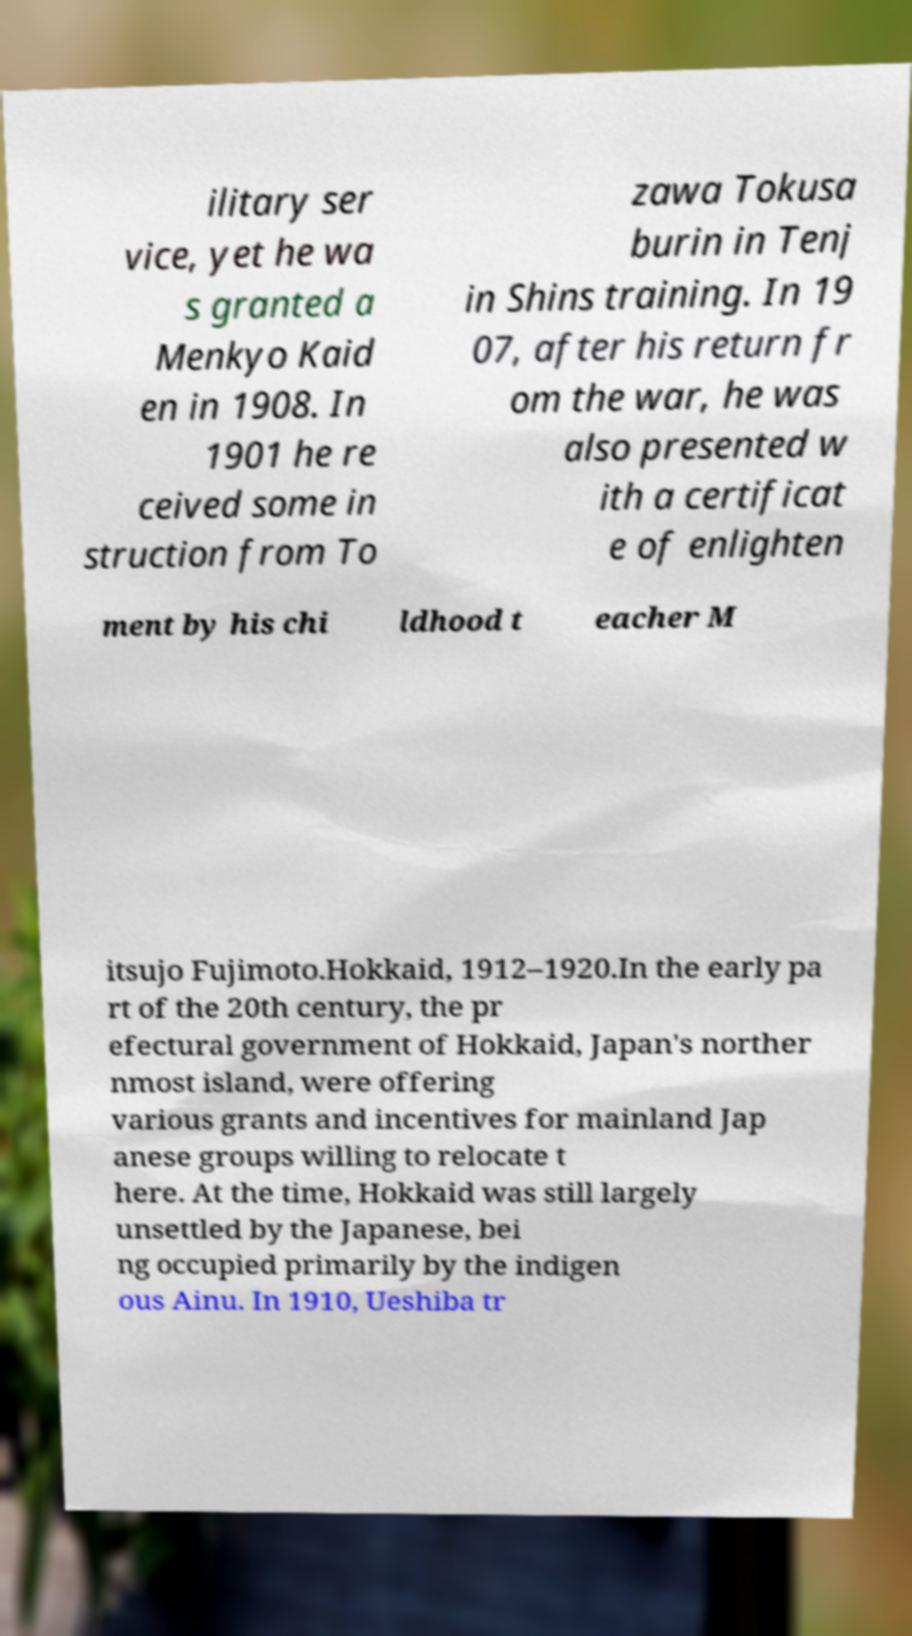For documentation purposes, I need the text within this image transcribed. Could you provide that? ilitary ser vice, yet he wa s granted a Menkyo Kaid en in 1908. In 1901 he re ceived some in struction from To zawa Tokusa burin in Tenj in Shins training. In 19 07, after his return fr om the war, he was also presented w ith a certificat e of enlighten ment by his chi ldhood t eacher M itsujo Fujimoto.Hokkaid, 1912–1920.In the early pa rt of the 20th century, the pr efectural government of Hokkaid, Japan's norther nmost island, were offering various grants and incentives for mainland Jap anese groups willing to relocate t here. At the time, Hokkaid was still largely unsettled by the Japanese, bei ng occupied primarily by the indigen ous Ainu. In 1910, Ueshiba tr 